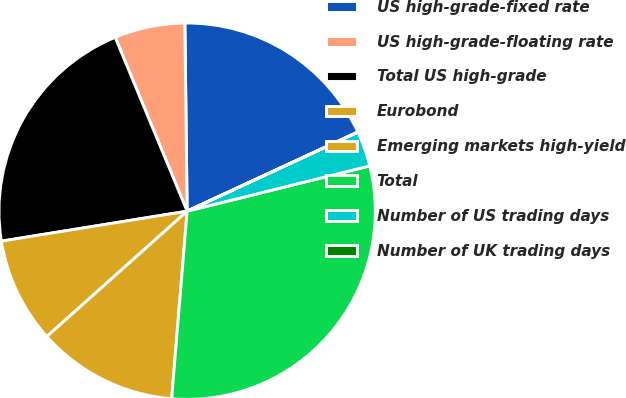<chart> <loc_0><loc_0><loc_500><loc_500><pie_chart><fcel>US high-grade-fixed rate<fcel>US high-grade-floating rate<fcel>Total US high-grade<fcel>Eurobond<fcel>Emerging markets high-yield<fcel>Total<fcel>Number of US trading days<fcel>Number of UK trading days<nl><fcel>18.28%<fcel>6.05%<fcel>21.3%<fcel>9.06%<fcel>12.08%<fcel>30.18%<fcel>3.03%<fcel>0.01%<nl></chart> 